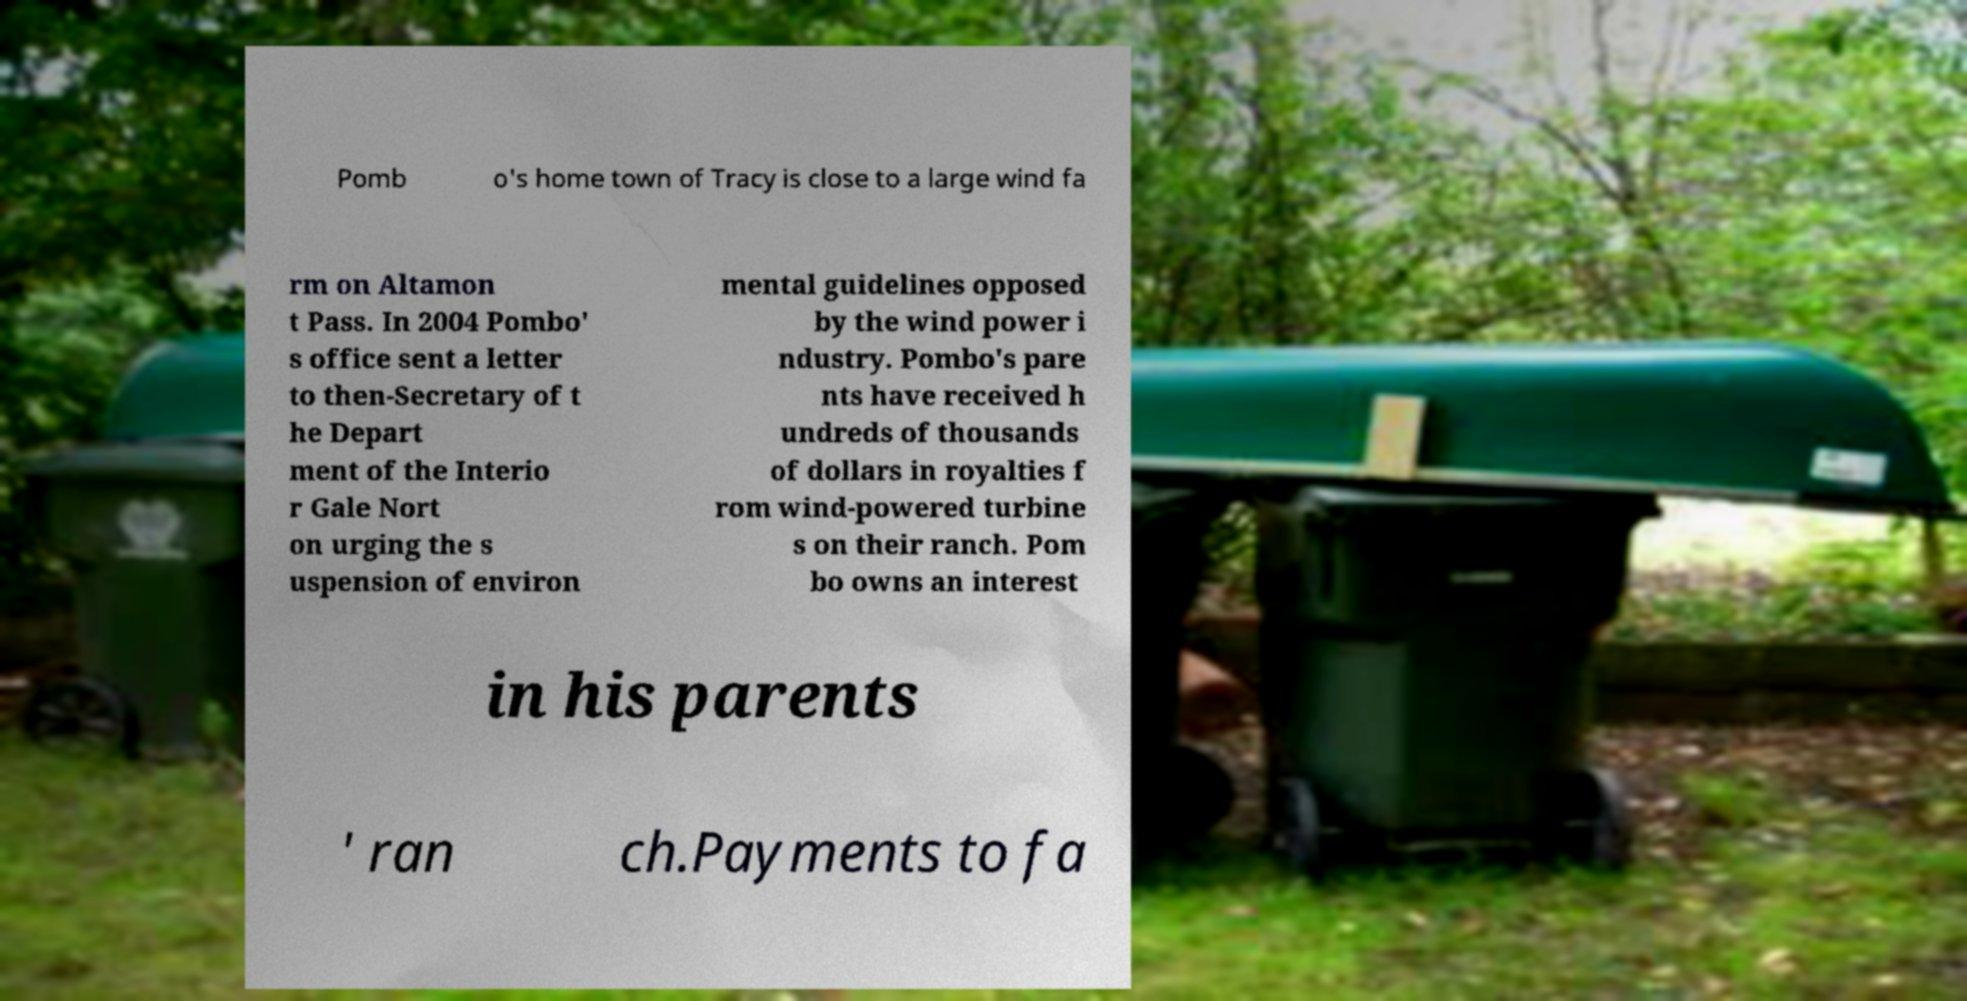Please read and relay the text visible in this image. What does it say? Pomb o's home town of Tracy is close to a large wind fa rm on Altamon t Pass. In 2004 Pombo' s office sent a letter to then-Secretary of t he Depart ment of the Interio r Gale Nort on urging the s uspension of environ mental guidelines opposed by the wind power i ndustry. Pombo's pare nts have received h undreds of thousands of dollars in royalties f rom wind-powered turbine s on their ranch. Pom bo owns an interest in his parents ' ran ch.Payments to fa 